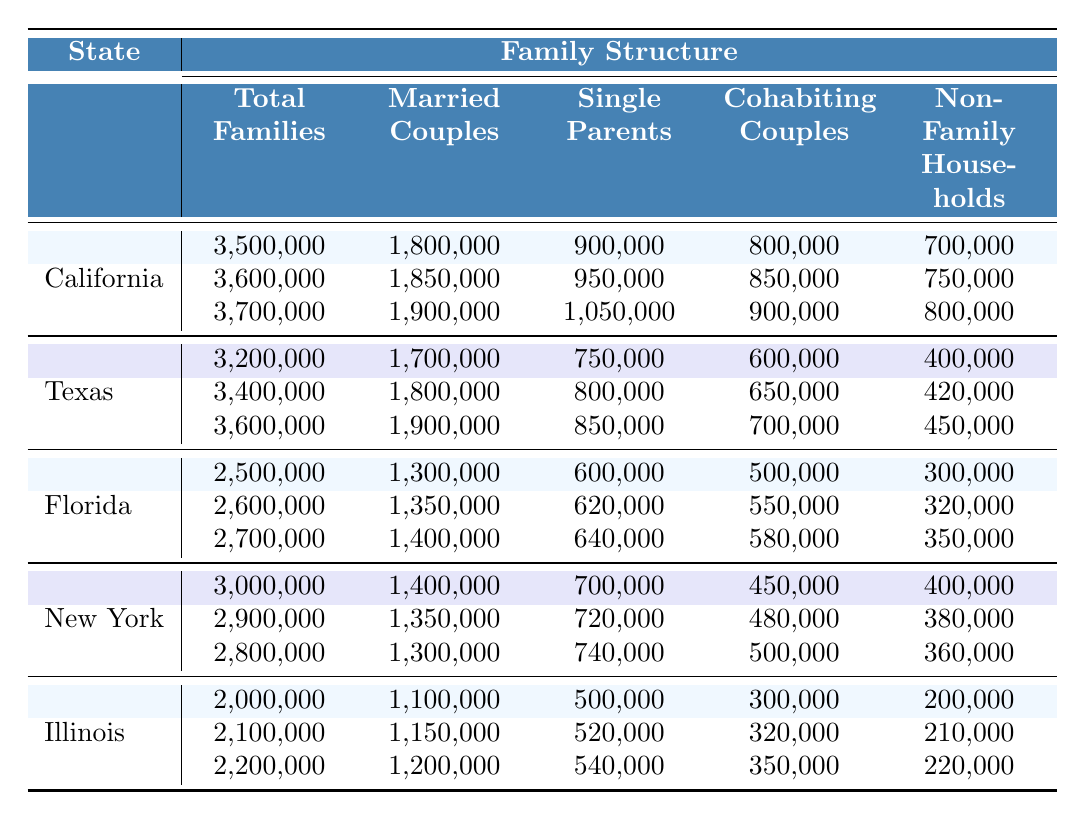What was the total number of families in California in 2020? In the table, under California, the row for the year 2020 shows that the total number of families is 3,700,000.
Answer: 3,700,000 How many married couples were there in Texas in 2015? Looking at the Texas row, for the year 2015, the number of married couples is 1,800,000.
Answer: 1,800,000 Which state had the highest number of single parents in 2020? By comparing the single parent numbers for 2020, California has 1,050,000, Texas has 850,000, Florida has 640,000, New York has 740,000, and Illinois has 540,000. California has the highest.
Answer: California What is the increase in total families in Florida from 2010 to 2020? In Florida, the total families in 2010 were 2,500,000 and in 2020 were 2,700,000. The increase is 2,700,000 - 2,500,000 = 200,000.
Answer: 200,000 How many non-family households are there in New York in 2015? For New York in the year 2015, the number of non-family households is 380,000 as seen in the corresponding row.
Answer: 380,000 What is the ratio of married couples to single parents in Illinois in 2020? In Illinois for 2020, there are 1,200,000 married couples and 540,000 single parents. The ratio is 1,200,000 / 540,000 = approximately 2.22.
Answer: 2.22 Did Texas see an increase in non-family households from 2010 to 2020? Examining the non-family households in Texas, in 2010 there were 400,000 and in 2020 there are 450,000. Since 450,000 > 400,000, this indicates an increase.
Answer: Yes Which state had the lowest number of total families in 2010? Looking at the total families in 2010, California had 3,500,000, Texas had 3,200,000, Florida had 2,500,000, New York had 3,000,000, and Illinois had 2,000,000. Illinois has the lowest number.
Answer: Illinois How much did the number of cohabiting couples increase in California from 2010 to 2020? For California, the number of cohabiting couples in 2010 was 800,000 and in 2020 it was 900,000. The increase is 900,000 - 800,000 = 100,000.
Answer: 100,000 Is there a trend of decreasing married couples in New York from 2010 to 2020? In New York, the number of married couples is 1,400,000 in 2010, 1,350,000 in 2015, and 1,300,000 in 2020. This shows a decreasing trend over the years.
Answer: Yes 